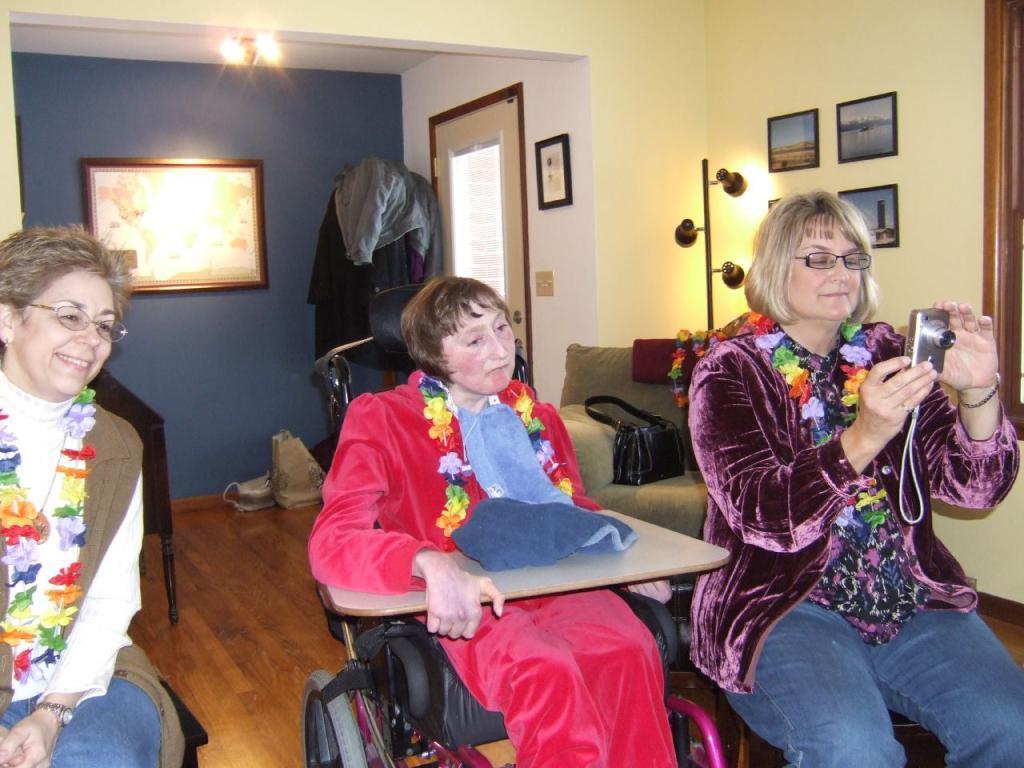Please provide a concise description of this image. In this picture we can see there are two people sitting and a person is sitting on a wheel chair. Behind the people there is a handbag on the couch and behind the couch there is a stand with lights and a wall with photo frames and a door. On the left side of the door there are some clothes and at the top there are lights and a woman is holding a camera. 